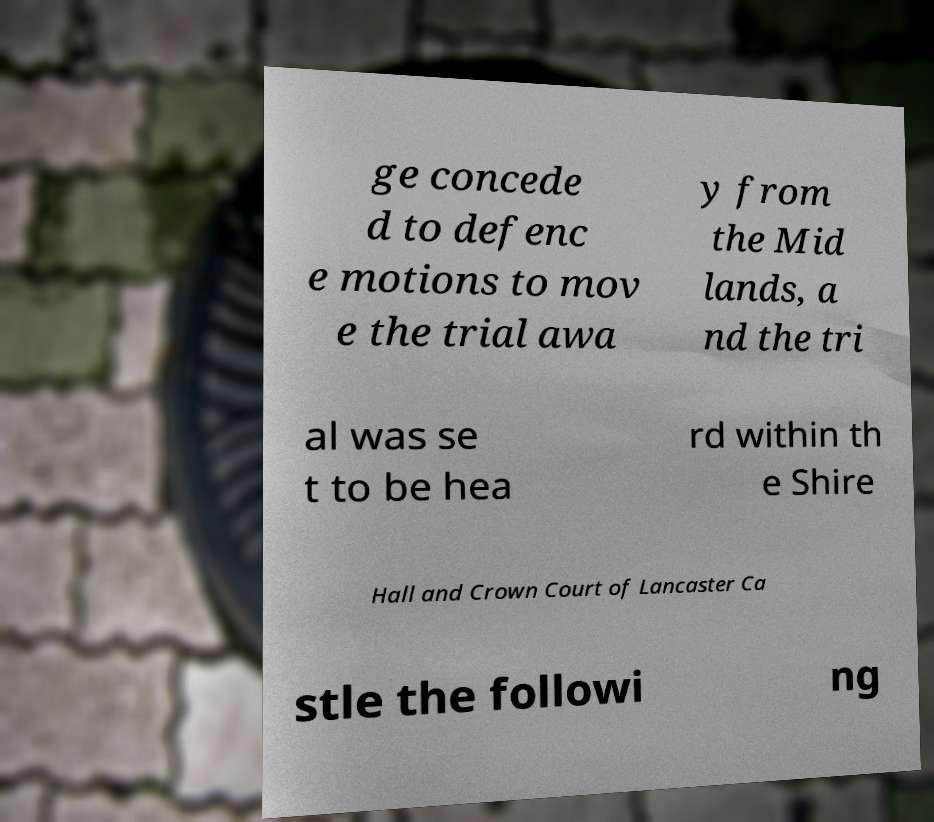For documentation purposes, I need the text within this image transcribed. Could you provide that? ge concede d to defenc e motions to mov e the trial awa y from the Mid lands, a nd the tri al was se t to be hea rd within th e Shire Hall and Crown Court of Lancaster Ca stle the followi ng 